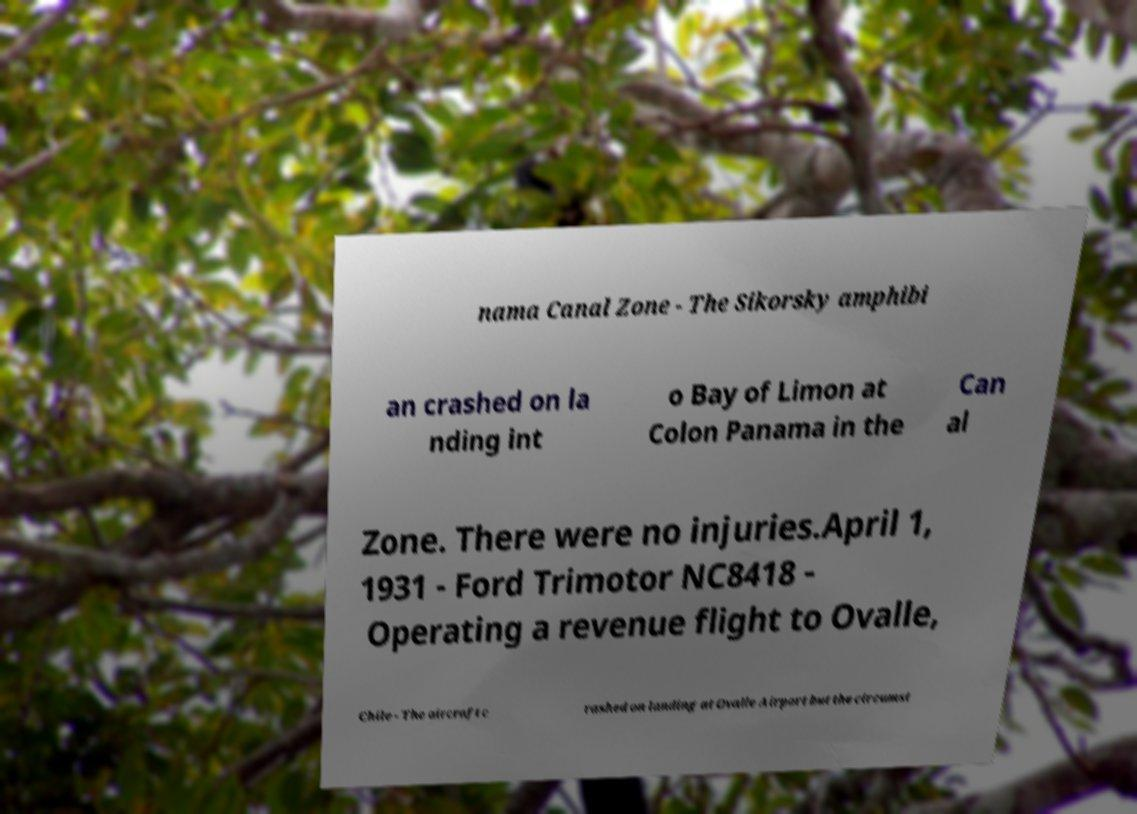Could you assist in decoding the text presented in this image and type it out clearly? nama Canal Zone - The Sikorsky amphibi an crashed on la nding int o Bay of Limon at Colon Panama in the Can al Zone. There were no injuries.April 1, 1931 - Ford Trimotor NC8418 - Operating a revenue flight to Ovalle, Chile - The aircraft c rashed on landing at Ovalle Airport but the circumst 